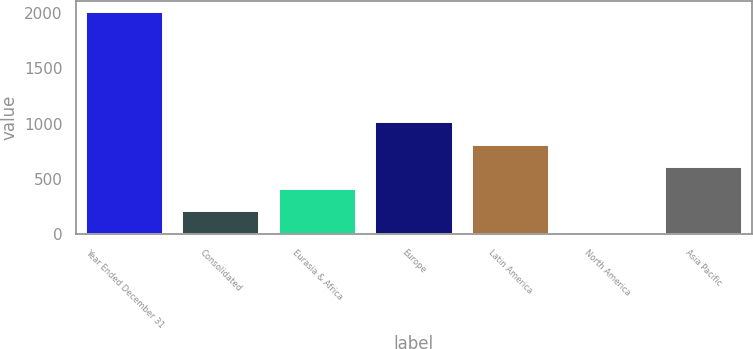Convert chart to OTSL. <chart><loc_0><loc_0><loc_500><loc_500><bar_chart><fcel>Year Ended December 31<fcel>Consolidated<fcel>Eurasia & Africa<fcel>Europe<fcel>Latin America<fcel>North America<fcel>Asia Pacific<nl><fcel>2013<fcel>211.47<fcel>411.64<fcel>1012.15<fcel>811.98<fcel>11.3<fcel>611.81<nl></chart> 